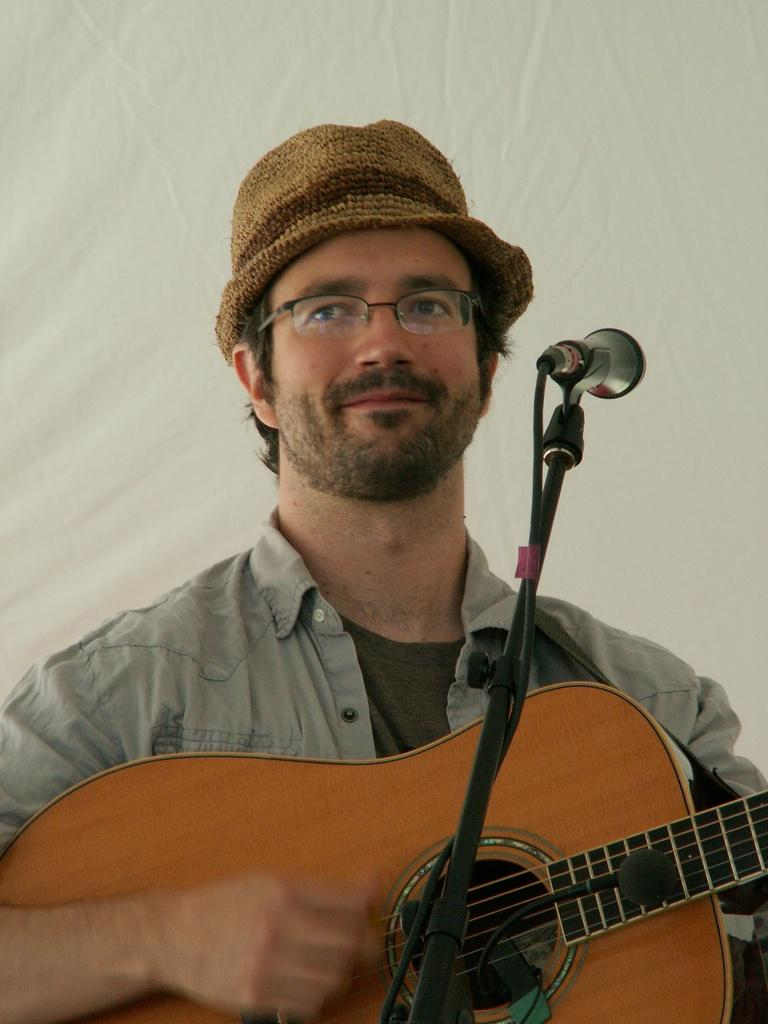Who is the main subject in the image? There is a man in the image. Where is the man located in the image? The man is at the center of the image. What is the man holding in the image? The man is holding a guitar. What object is in front of the man? There is a microphone in front of the man. What type of accessory is the man wearing? The man is wearing a hat around his head. What type of can does the man use to fight in the image? There is no can or fighting depicted in the image; the man is holding a guitar and standing near a microphone. 